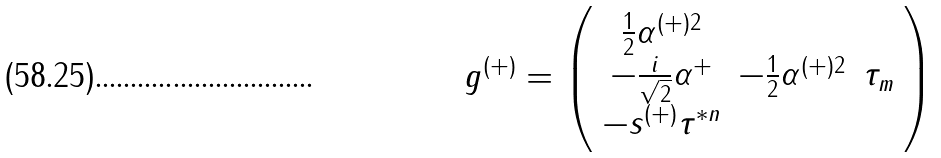Convert formula to latex. <formula><loc_0><loc_0><loc_500><loc_500>g ^ { ( + ) } = \left ( \begin{array} { c c c } { { \frac { 1 } { 2 } \alpha ^ { ( + ) 2 } } } \\ { { - \frac { i } { \sqrt { 2 } } \alpha ^ { + } } } & { { - \frac { 1 } { 2 } \alpha ^ { ( + ) 2 } } } & { { \tau _ { m } } } \\ { { - s ^ { ( + ) } \tau ^ { * n } } } \end{array} \right )</formula> 